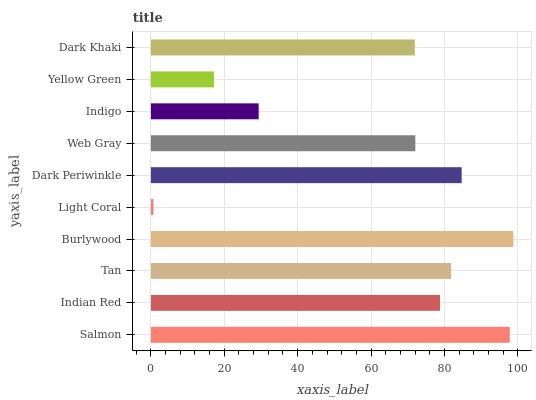Is Light Coral the minimum?
Answer yes or no. Yes. Is Burlywood the maximum?
Answer yes or no. Yes. Is Indian Red the minimum?
Answer yes or no. No. Is Indian Red the maximum?
Answer yes or no. No. Is Salmon greater than Indian Red?
Answer yes or no. Yes. Is Indian Red less than Salmon?
Answer yes or no. Yes. Is Indian Red greater than Salmon?
Answer yes or no. No. Is Salmon less than Indian Red?
Answer yes or no. No. Is Indian Red the high median?
Answer yes or no. Yes. Is Web Gray the low median?
Answer yes or no. Yes. Is Tan the high median?
Answer yes or no. No. Is Tan the low median?
Answer yes or no. No. 